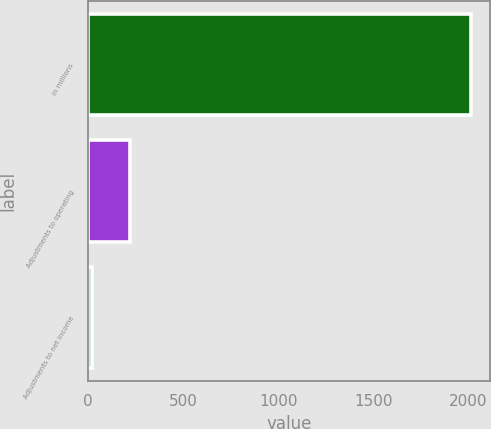<chart> <loc_0><loc_0><loc_500><loc_500><bar_chart><fcel>in millions<fcel>Adjustments to operating<fcel>Adjustments to net income<nl><fcel>2015<fcel>219.77<fcel>20.3<nl></chart> 